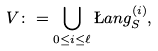<formula> <loc_0><loc_0><loc_500><loc_500>V \colon = \bigcup _ { 0 \leq i \leq \ell } \L a n g _ { S } ^ { ( i ) } ,</formula> 